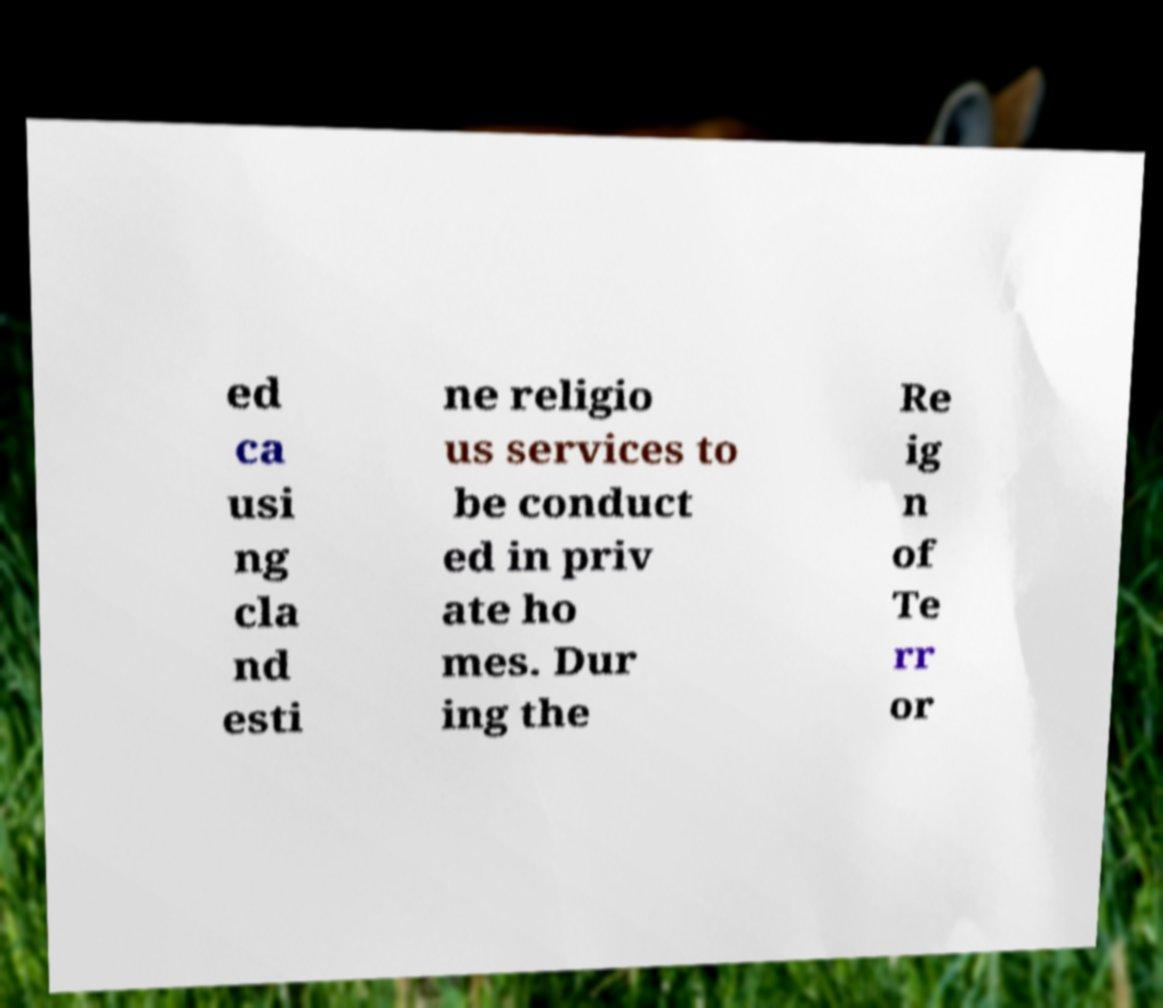Could you assist in decoding the text presented in this image and type it out clearly? ed ca usi ng cla nd esti ne religio us services to be conduct ed in priv ate ho mes. Dur ing the Re ig n of Te rr or 